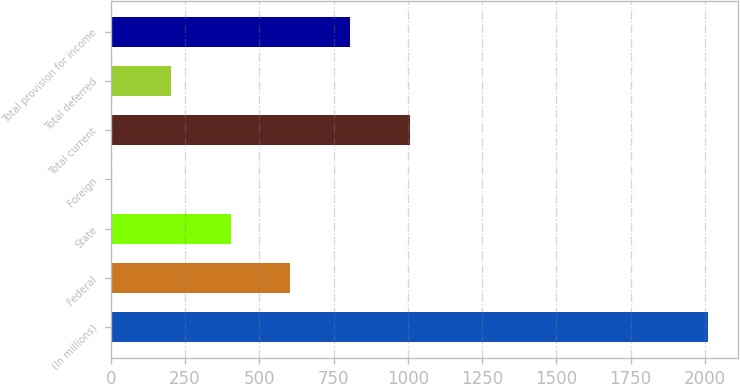<chart> <loc_0><loc_0><loc_500><loc_500><bar_chart><fcel>(In millions)<fcel>Federal<fcel>State<fcel>Foreign<fcel>Total current<fcel>Total deferred<fcel>Total provision for income<nl><fcel>2012<fcel>605<fcel>404<fcel>2<fcel>1007<fcel>203<fcel>806<nl></chart> 